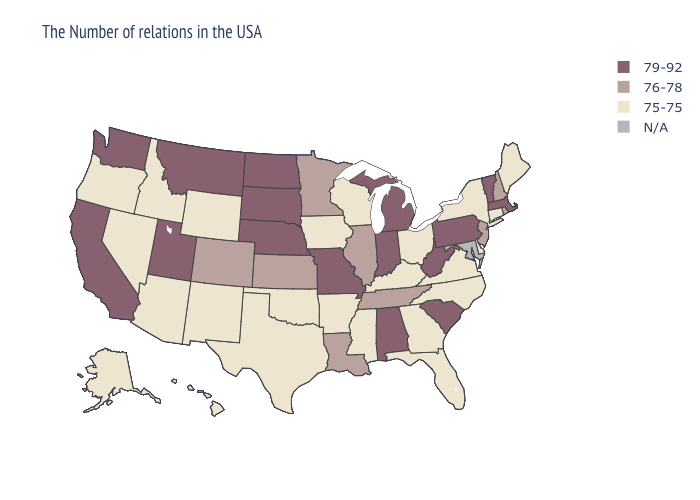Name the states that have a value in the range 75-75?
Be succinct. Maine, Connecticut, New York, Delaware, Virginia, North Carolina, Ohio, Florida, Georgia, Kentucky, Wisconsin, Mississippi, Arkansas, Iowa, Oklahoma, Texas, Wyoming, New Mexico, Arizona, Idaho, Nevada, Oregon, Alaska, Hawaii. Which states hav the highest value in the West?
Give a very brief answer. Utah, Montana, California, Washington. What is the value of Texas?
Keep it brief. 75-75. What is the value of Alaska?
Write a very short answer. 75-75. What is the highest value in the Northeast ?
Short answer required. 79-92. What is the value of Wyoming?
Quick response, please. 75-75. What is the value of Vermont?
Concise answer only. 79-92. What is the value of Delaware?
Quick response, please. 75-75. Among the states that border Washington , which have the lowest value?
Answer briefly. Idaho, Oregon. Does Washington have the highest value in the USA?
Quick response, please. Yes. Name the states that have a value in the range 79-92?
Be succinct. Massachusetts, Vermont, Pennsylvania, South Carolina, West Virginia, Michigan, Indiana, Alabama, Missouri, Nebraska, South Dakota, North Dakota, Utah, Montana, California, Washington. Name the states that have a value in the range 79-92?
Concise answer only. Massachusetts, Vermont, Pennsylvania, South Carolina, West Virginia, Michigan, Indiana, Alabama, Missouri, Nebraska, South Dakota, North Dakota, Utah, Montana, California, Washington. What is the value of Montana?
Quick response, please. 79-92. 